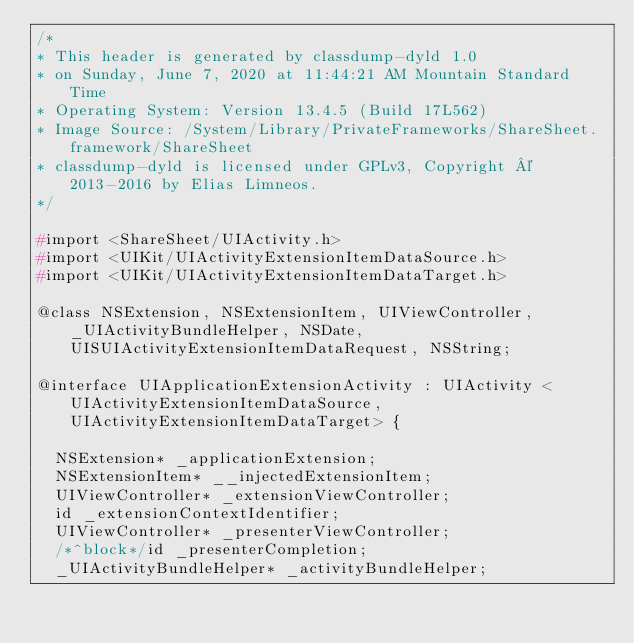<code> <loc_0><loc_0><loc_500><loc_500><_C_>/*
* This header is generated by classdump-dyld 1.0
* on Sunday, June 7, 2020 at 11:44:21 AM Mountain Standard Time
* Operating System: Version 13.4.5 (Build 17L562)
* Image Source: /System/Library/PrivateFrameworks/ShareSheet.framework/ShareSheet
* classdump-dyld is licensed under GPLv3, Copyright © 2013-2016 by Elias Limneos.
*/

#import <ShareSheet/UIActivity.h>
#import <UIKit/UIActivityExtensionItemDataSource.h>
#import <UIKit/UIActivityExtensionItemDataTarget.h>

@class NSExtension, NSExtensionItem, UIViewController, _UIActivityBundleHelper, NSDate, UISUIActivityExtensionItemDataRequest, NSString;

@interface UIApplicationExtensionActivity : UIActivity <UIActivityExtensionItemDataSource, UIActivityExtensionItemDataTarget> {

	NSExtension* _applicationExtension;
	NSExtensionItem* __injectedExtensionItem;
	UIViewController* _extensionViewController;
	id _extensionContextIdentifier;
	UIViewController* _presenterViewController;
	/*^block*/id _presenterCompletion;
	_UIActivityBundleHelper* _activityBundleHelper;</code> 